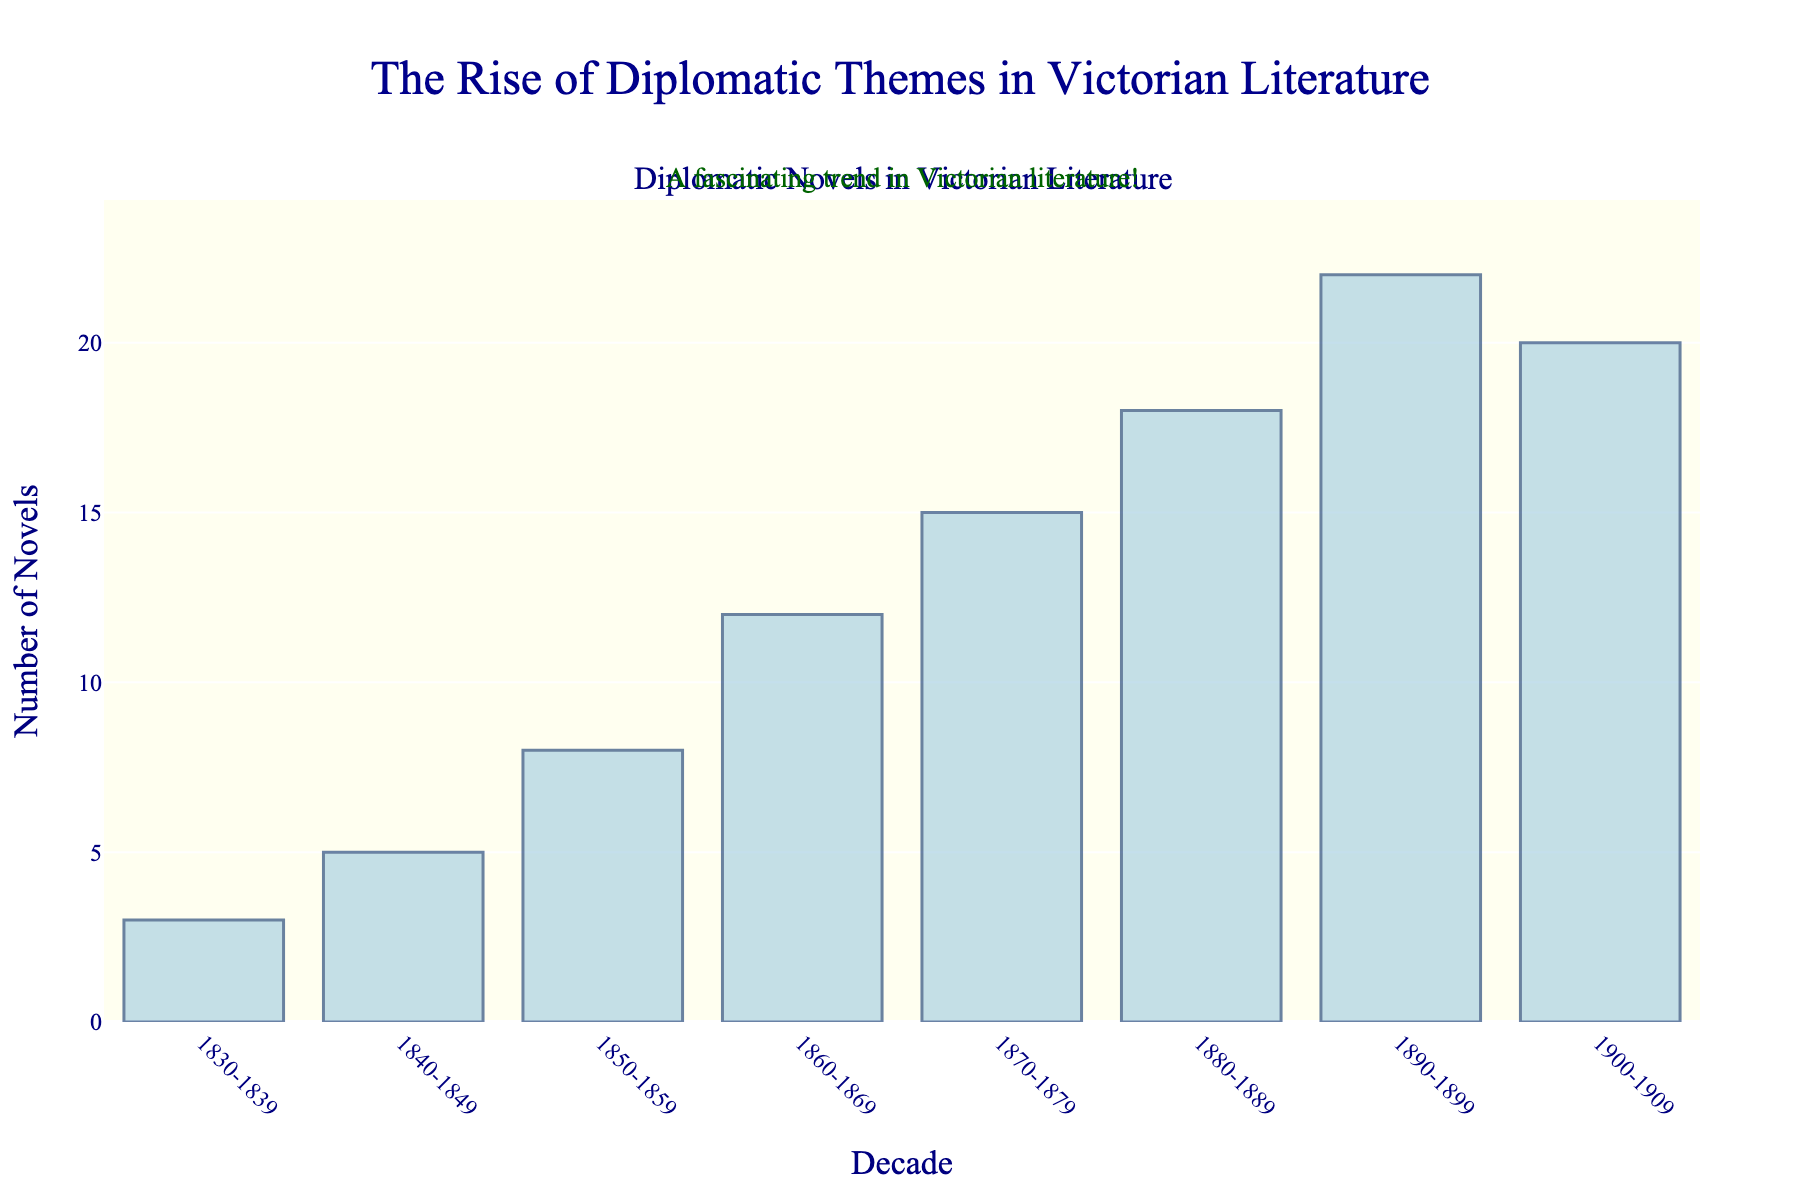Which decade saw the highest number of diplomatic-themed novels published? Look at the bar representing the decade with the tallest height. The tallest bar corresponds to 1890-1899.
Answer: 1890-1899 Which decade experienced a decrease in the number of diplomatic-themed novels after a previous increase? Compare the values for each consecutive pair of decades. The number of novels increased from 1880-1889 (18) to 1890-1899 (22) and then decreased in 1900-1909 (20).
Answer: 1900-1909 How many more novels were published in 1890-1899 compared to 1830-1839? Subtract the number of novels in 1830-1839 (3) from the number in 1890-1899 (22). 22 - 3 = 19.
Answer: 19 What is the average number of novels published per decade across all the decades shown? Sum the number of novels for all decades and then divide by the number of decades. The total novels are 3 + 5 + 8 + 12 + 15 + 18 + 22 + 20 = 103. There are 8 decades, so the average is 103 / 8.
Answer: 12.875 What is the total number of novels published from 1850 to 1899? Sum the novels published in the decades from 1850-1859 to 1890-1899: 8 + 12 + 15 + 18 + 22 = 75.
Answer: 75 Between which two consecutive decades was the increase in novels most significant? Calculate the difference between each pair of consecutive decades and find the maximum difference: 
1840-1849 - 1830-1839 = 5 - 3 = 2 
1850-1859 - 1840-1849 = 8 - 5 = 3 
1860-1869 - 1850-1859 = 12 - 8 = 4 
1870-1879 - 1860-1869 = 15 - 12 = 3 
1880-1889 - 1870-1879 = 18 - 15 = 3 
1890-1899 - 1880-1889 = 22 - 18 = 4 
1900-1909 - 1890-1899 = 20 - 22 = -2 
The most significant increase is 1860-1869 over 1850-1859 and 1890-1899 over 1880-1889, both being 4.
Answer: 1860-1869 and 1890-1899 